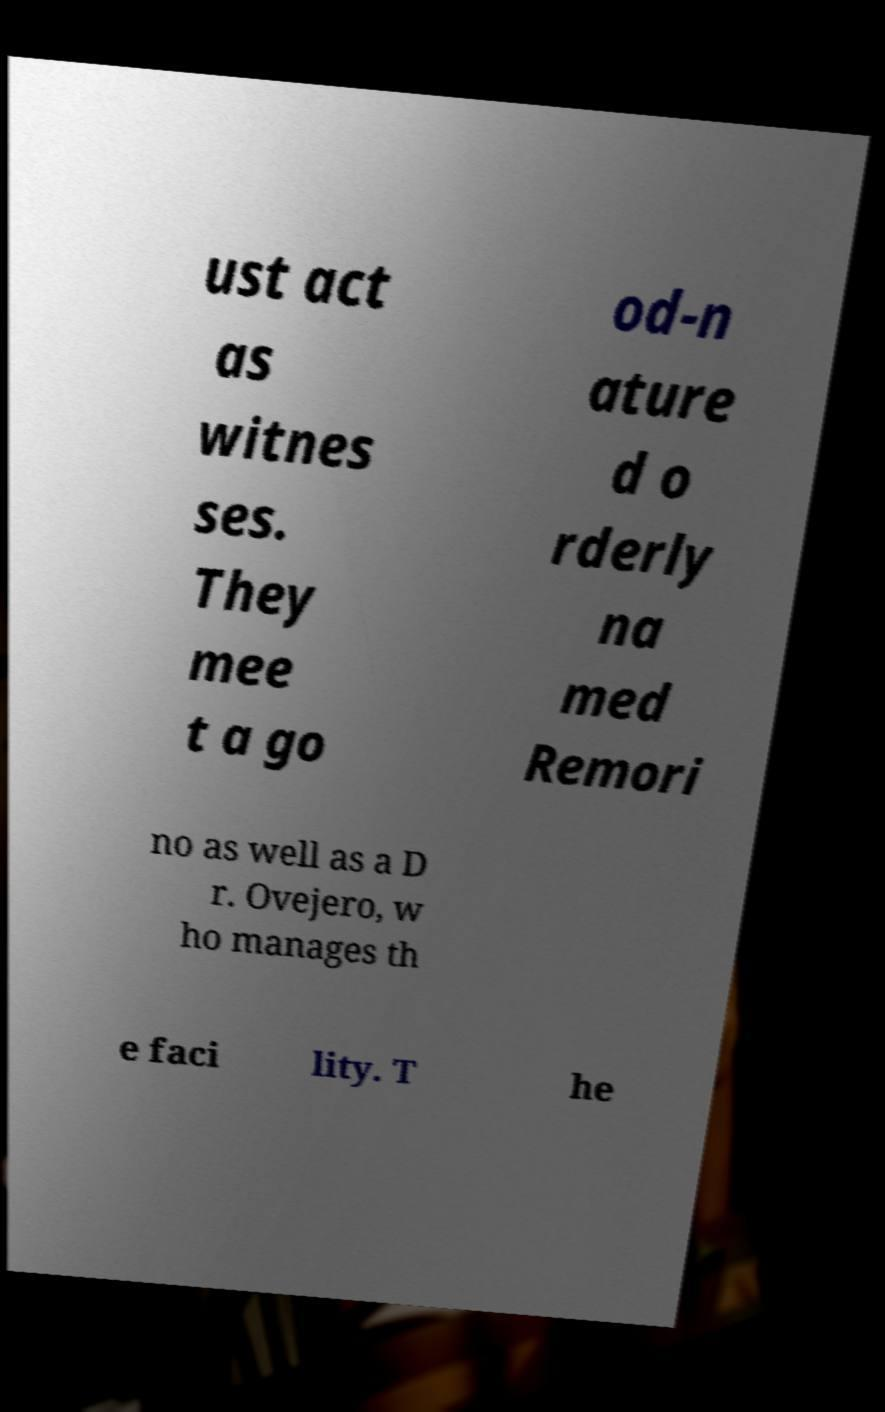Could you assist in decoding the text presented in this image and type it out clearly? ust act as witnes ses. They mee t a go od-n ature d o rderly na med Remori no as well as a D r. Ovejero, w ho manages th e faci lity. T he 